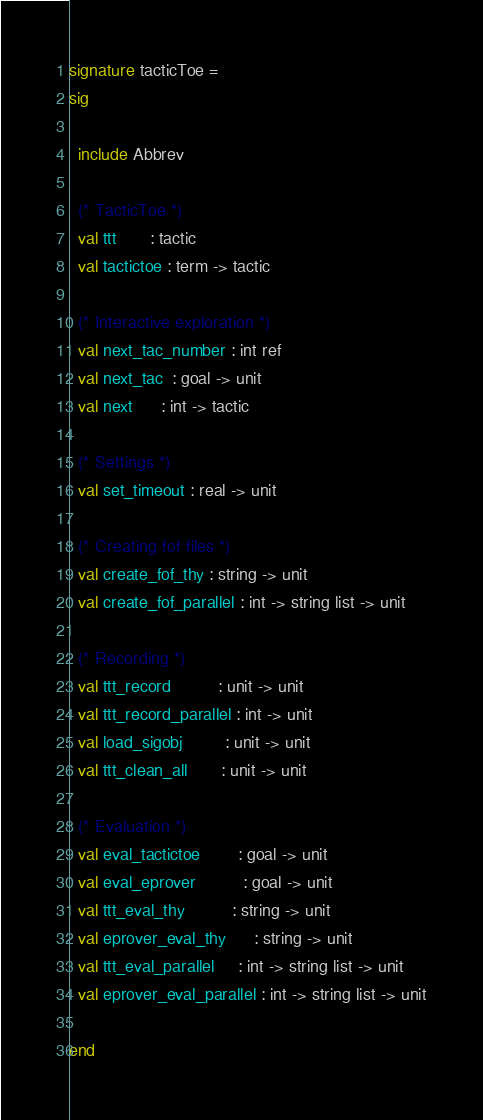Convert code to text. <code><loc_0><loc_0><loc_500><loc_500><_SML_>signature tacticToe =
sig

  include Abbrev

  (* TacticToe *)
  val ttt       : tactic
  val tactictoe : term -> tactic

  (* Interactive exploration *)
  val next_tac_number : int ref
  val next_tac  : goal -> unit
  val next      : int -> tactic
  
  (* Settings *)
  val set_timeout : real -> unit
  
  (* Creating fof files *)
  val create_fof_thy : string -> unit
  val create_fof_parallel : int -> string list -> unit
  
  (* Recording *)
  val ttt_record          : unit -> unit
  val ttt_record_parallel : int -> unit
  val load_sigobj         : unit -> unit
  val ttt_clean_all       : unit -> unit

  (* Evaluation *)
  val eval_tactictoe        : goal -> unit
  val eval_eprover          : goal -> unit
  val ttt_eval_thy          : string -> unit
  val eprover_eval_thy      : string -> unit
  val ttt_eval_parallel     : int -> string list -> unit
  val eprover_eval_parallel : int -> string list -> unit

end
</code> 